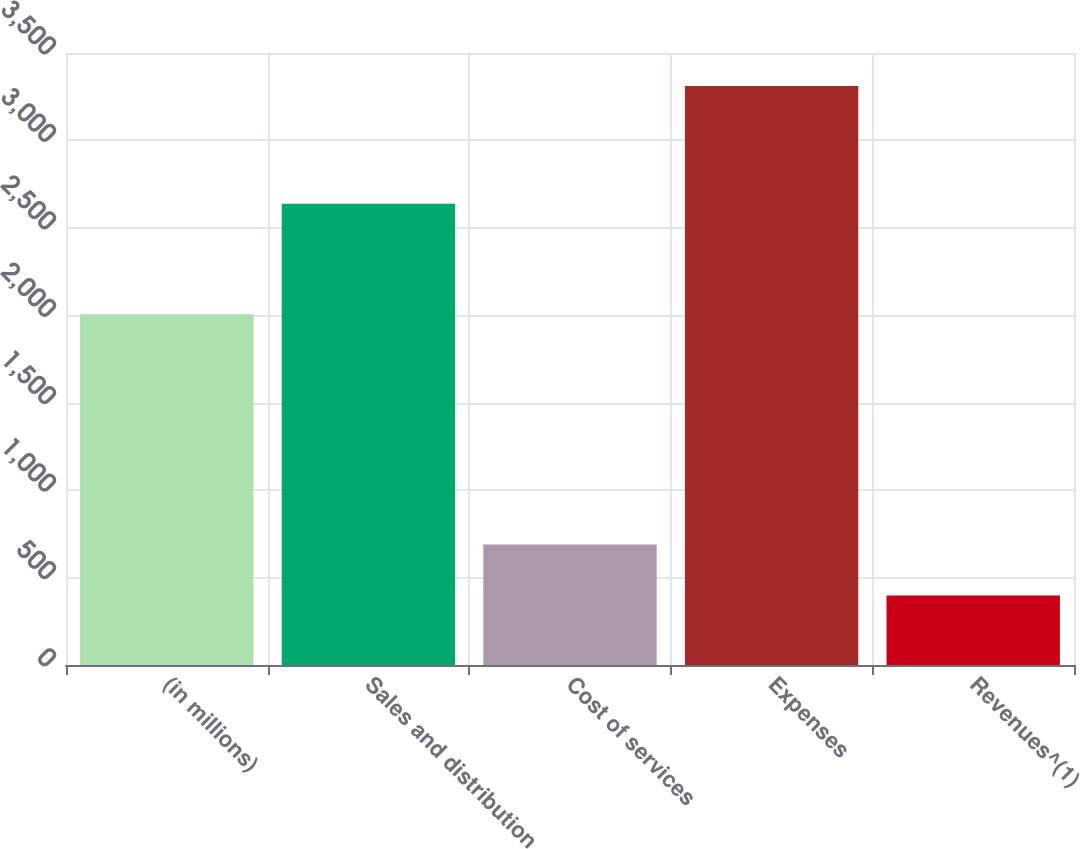<chart> <loc_0><loc_0><loc_500><loc_500><bar_chart><fcel>(in millions)<fcel>Sales and distribution<fcel>Cost of services<fcel>Expenses<fcel>Revenues^(1)<nl><fcel>2006<fcel>2638<fcel>689.3<fcel>3311<fcel>398<nl></chart> 